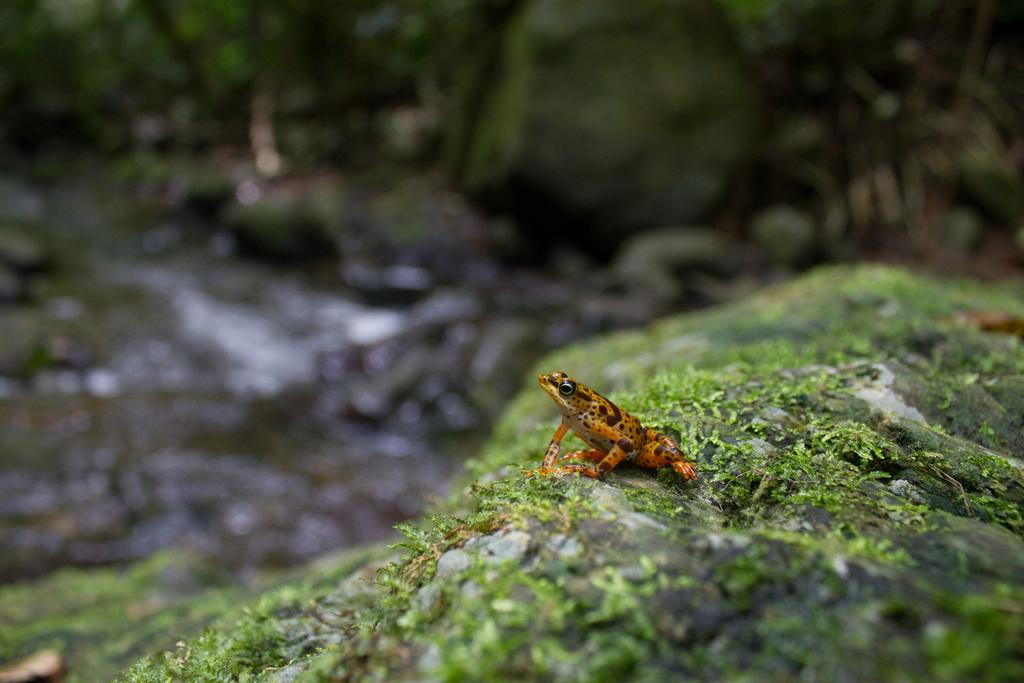What is the main subject of the image? There is a frog in the center of the image. Where is the frog located? The frog is on the grassland. Can you describe the background of the image? The background area of the image is blurred. What type of goat can be seen playing with paste in the image? There is no goat or paste present in the image; it features a frog on the grassland. 